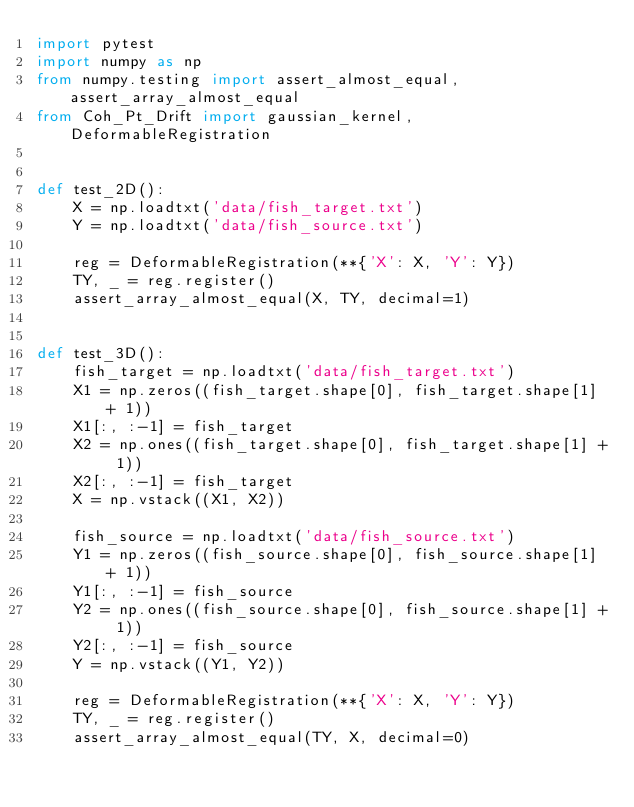<code> <loc_0><loc_0><loc_500><loc_500><_Python_>import pytest
import numpy as np
from numpy.testing import assert_almost_equal, assert_array_almost_equal
from Coh_Pt_Drift import gaussian_kernel, DeformableRegistration


def test_2D():
    X = np.loadtxt('data/fish_target.txt')
    Y = np.loadtxt('data/fish_source.txt')

    reg = DeformableRegistration(**{'X': X, 'Y': Y})
    TY, _ = reg.register()
    assert_array_almost_equal(X, TY, decimal=1)


def test_3D():
    fish_target = np.loadtxt('data/fish_target.txt')
    X1 = np.zeros((fish_target.shape[0], fish_target.shape[1] + 1))
    X1[:, :-1] = fish_target
    X2 = np.ones((fish_target.shape[0], fish_target.shape[1] + 1))
    X2[:, :-1] = fish_target
    X = np.vstack((X1, X2))

    fish_source = np.loadtxt('data/fish_source.txt')
    Y1 = np.zeros((fish_source.shape[0], fish_source.shape[1] + 1))
    Y1[:, :-1] = fish_source
    Y2 = np.ones((fish_source.shape[0], fish_source.shape[1] + 1))
    Y2[:, :-1] = fish_source
    Y = np.vstack((Y1, Y2))

    reg = DeformableRegistration(**{'X': X, 'Y': Y})
    TY, _ = reg.register()
    assert_array_almost_equal(TY, X, decimal=0)
</code> 